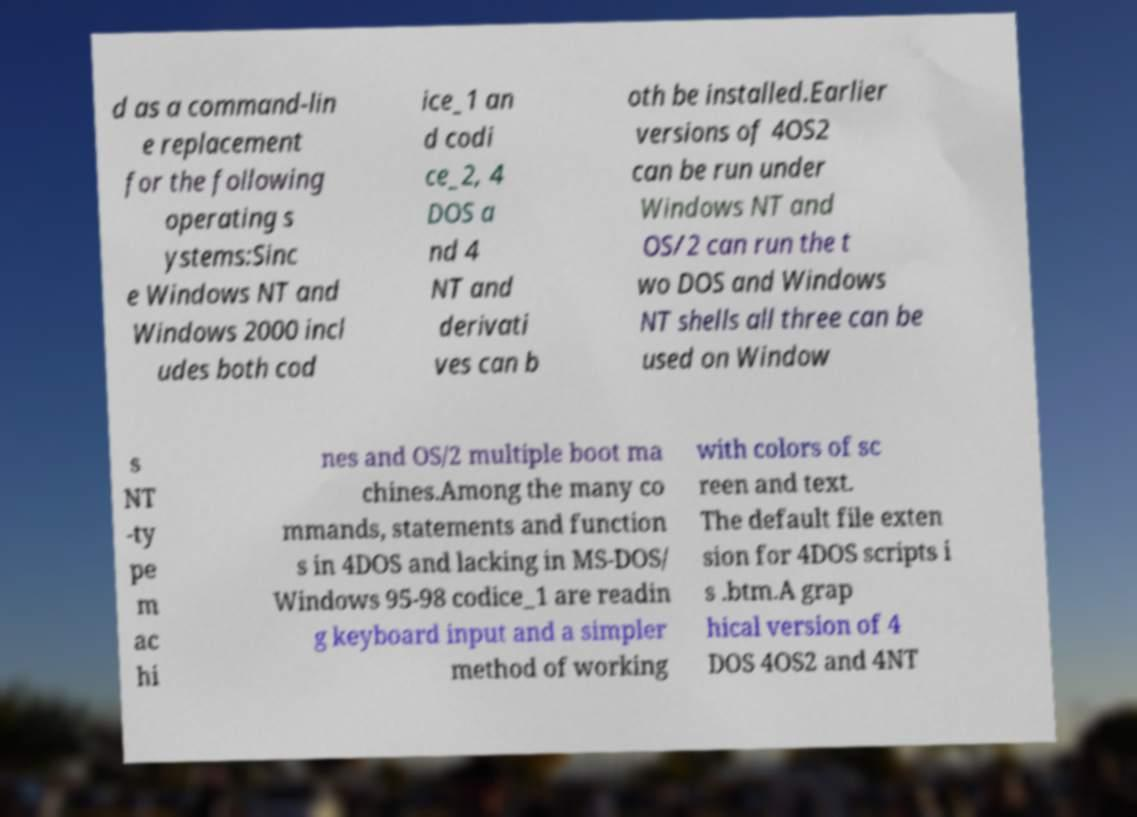What messages or text are displayed in this image? I need them in a readable, typed format. d as a command-lin e replacement for the following operating s ystems:Sinc e Windows NT and Windows 2000 incl udes both cod ice_1 an d codi ce_2, 4 DOS a nd 4 NT and derivati ves can b oth be installed.Earlier versions of 4OS2 can be run under Windows NT and OS/2 can run the t wo DOS and Windows NT shells all three can be used on Window s NT -ty pe m ac hi nes and OS/2 multiple boot ma chines.Among the many co mmands, statements and function s in 4DOS and lacking in MS-DOS/ Windows 95-98 codice_1 are readin g keyboard input and a simpler method of working with colors of sc reen and text. The default file exten sion for 4DOS scripts i s .btm.A grap hical version of 4 DOS 4OS2 and 4NT 